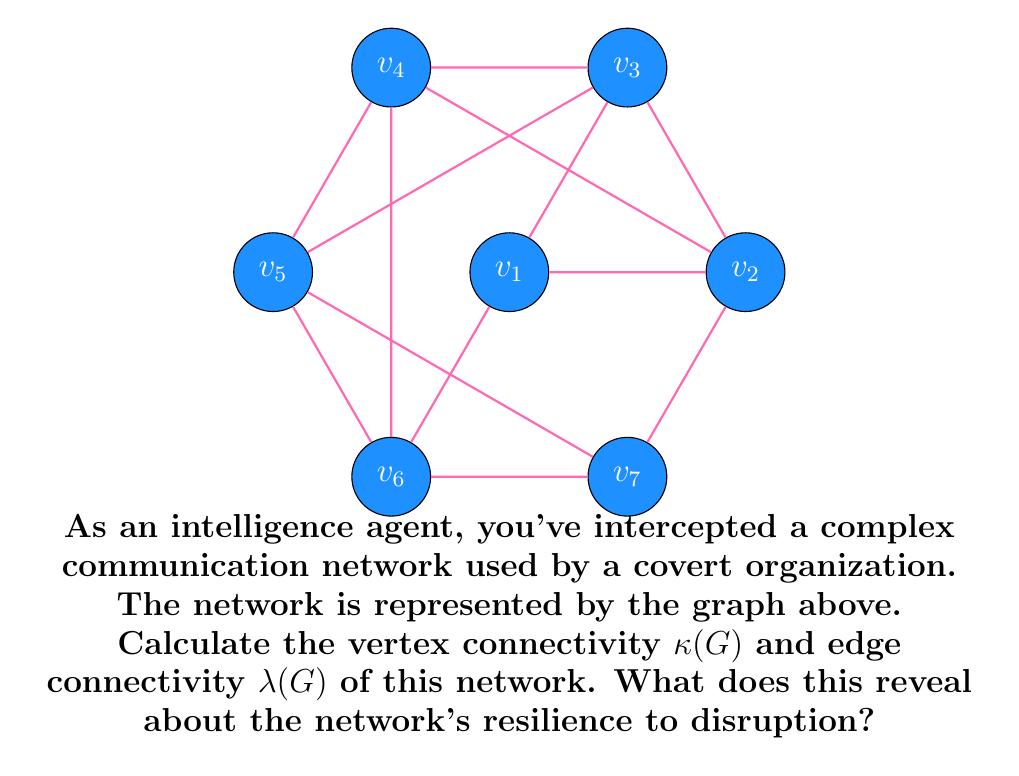Provide a solution to this math problem. To solve this problem, we need to determine the vertex connectivity $\kappa(G)$ and edge connectivity $\lambda(G)$ of the given graph.

Step 1: Analyze the graph structure
The graph is a 7-vertex graph where each vertex is connected to 4 other vertices. This is known as a 4-regular graph.

Step 2: Calculate vertex connectivity $\kappa(G)$
Vertex connectivity is the minimum number of vertices that need to be removed to disconnect the graph.
- Removing any single vertex leaves the graph connected.
- Removing any two adjacent vertices disconnects the graph.
Therefore, $\kappa(G) = 2$.

Step 3: Calculate edge connectivity $\lambda(G)$
Edge connectivity is the minimum number of edges that need to be removed to disconnect the graph.
- Removing any 3 edges incident to a single vertex disconnects that vertex from the graph.
- There is no way to disconnect the graph by removing fewer than 3 edges.
Therefore, $\lambda(G) = 3$.

Step 4: Interpret the results
For any graph G, we have the inequality: $\kappa(G) \leq \lambda(G) \leq \delta(G)$, where $\delta(G)$ is the minimum degree of the graph.

In this case:
$\kappa(G) = 2$
$\lambda(G) = 3$
$\delta(G) = 4$ (since it's a 4-regular graph)

This confirms that the inequality holds: $2 \leq 3 \leq 4$.

The network's resilience to disruption can be interpreted as follows:
- It takes at least 2 compromised nodes (agents) to potentially break the network's connectivity.
- It takes at least 3 compromised connections to potentially break the network's connectivity.
- The network is more resilient to edge failures than to vertex failures.
Answer: $\kappa(G) = 2$, $\lambda(G) = 3$. The network is moderately resilient, more vulnerable to node compromise than link disruption. 